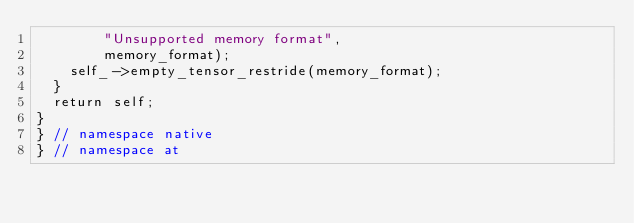Convert code to text. <code><loc_0><loc_0><loc_500><loc_500><_Cuda_>        "Unsupported memory format",
        memory_format);
    self_->empty_tensor_restride(memory_format);
  }
  return self;
}
} // namespace native
} // namespace at
</code> 